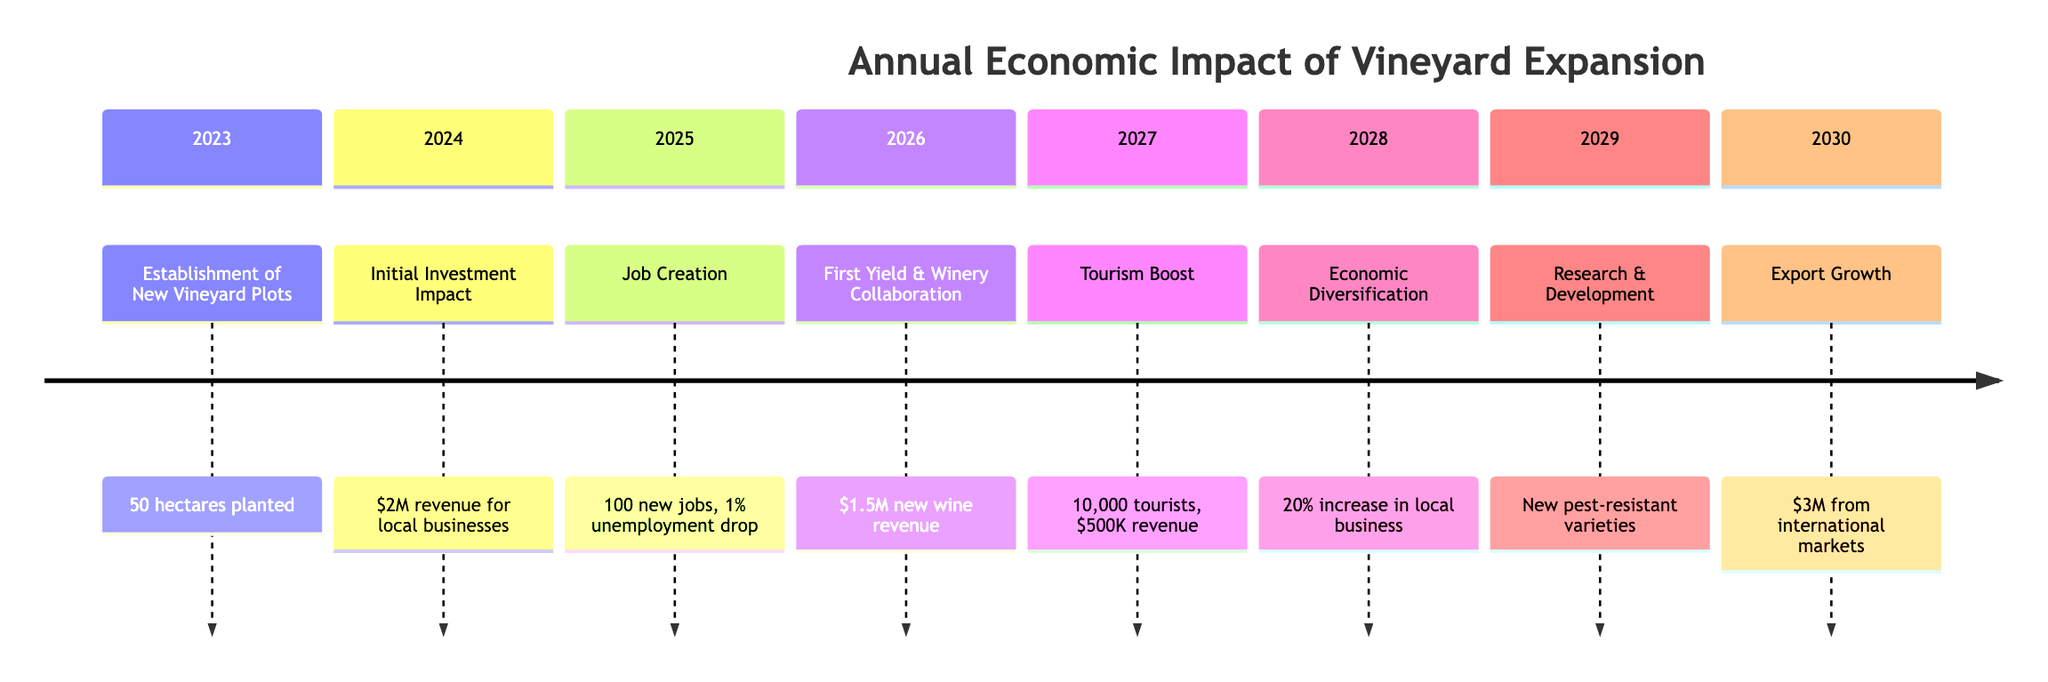What year did the first yield occur? The timeline specifies that the first significant grape yield occurred in 2026. Therefore, identifying the year directly references the year mentioned beside the "First Yield & Local Winery Collaboration" event.
Answer: 2026 How much revenue did the local businesses receive in 2024? According to the timeline, the "Initial Investment Impact" in 2024 resulted in $2 million in revenue for local businesses. This value is explicitly stated in the details of that event.
Answer: $2 million What is the percentage increase in patronage for local businesses in 2028? The timeline notes that the economic diversification in 2028 led to a 20% increase in patronage for ancillary businesses like local restaurants and bed-and-breakfasts. This percentage is directly included in the details for that year.
Answer: 20% How many new jobs were created in 2025? The timeline indicates that 100 new jobs were generated in 2025 due to the vineyard operations, as specified in the "Job Creation in Vineyard Operations" section. This number is stated directly in the details.
Answer: 100 What was the revenue generated from wine tourism in 2027? The timeline states that wine tourism initiatives in 2027 attracted 10,000 additional tourists and generated $500,000 in tourism revenue. The relevant revenue amount is indicated clearly within the event's details.
Answer: $500,000 What was the total revenue from exports by 2030? The timeline specifies that the first exports of locally produced wine in 2030 generated $3 million in revenue. This total revenue figure can be found specifically mentioned under "Export Growth."
Answer: $3 million Which year saw the establishment of new vineyard plots? The timeline shows that new vineyard plots were established in 2023, as indicated in the "Establishment of New Vineyard Plots" section. Thus, this year can be directly referenced from that event.
Answer: 2023 What kind of partnership was formed in 2026? The timeline details that in 2026, partnerships were established with local wineries, particularly after the first significant grape yield, indicating a collaboration focused on wine production. This kind of partnership is specifically highlighted in the section.
Answer: local wineries In which year did wine tourism initiatives launch? According to the timeline, wine tourism initiatives were launched in 2027, as directly stated in the corresponding event. This chronological information is clearly outlined in that year's details.
Answer: 2027 